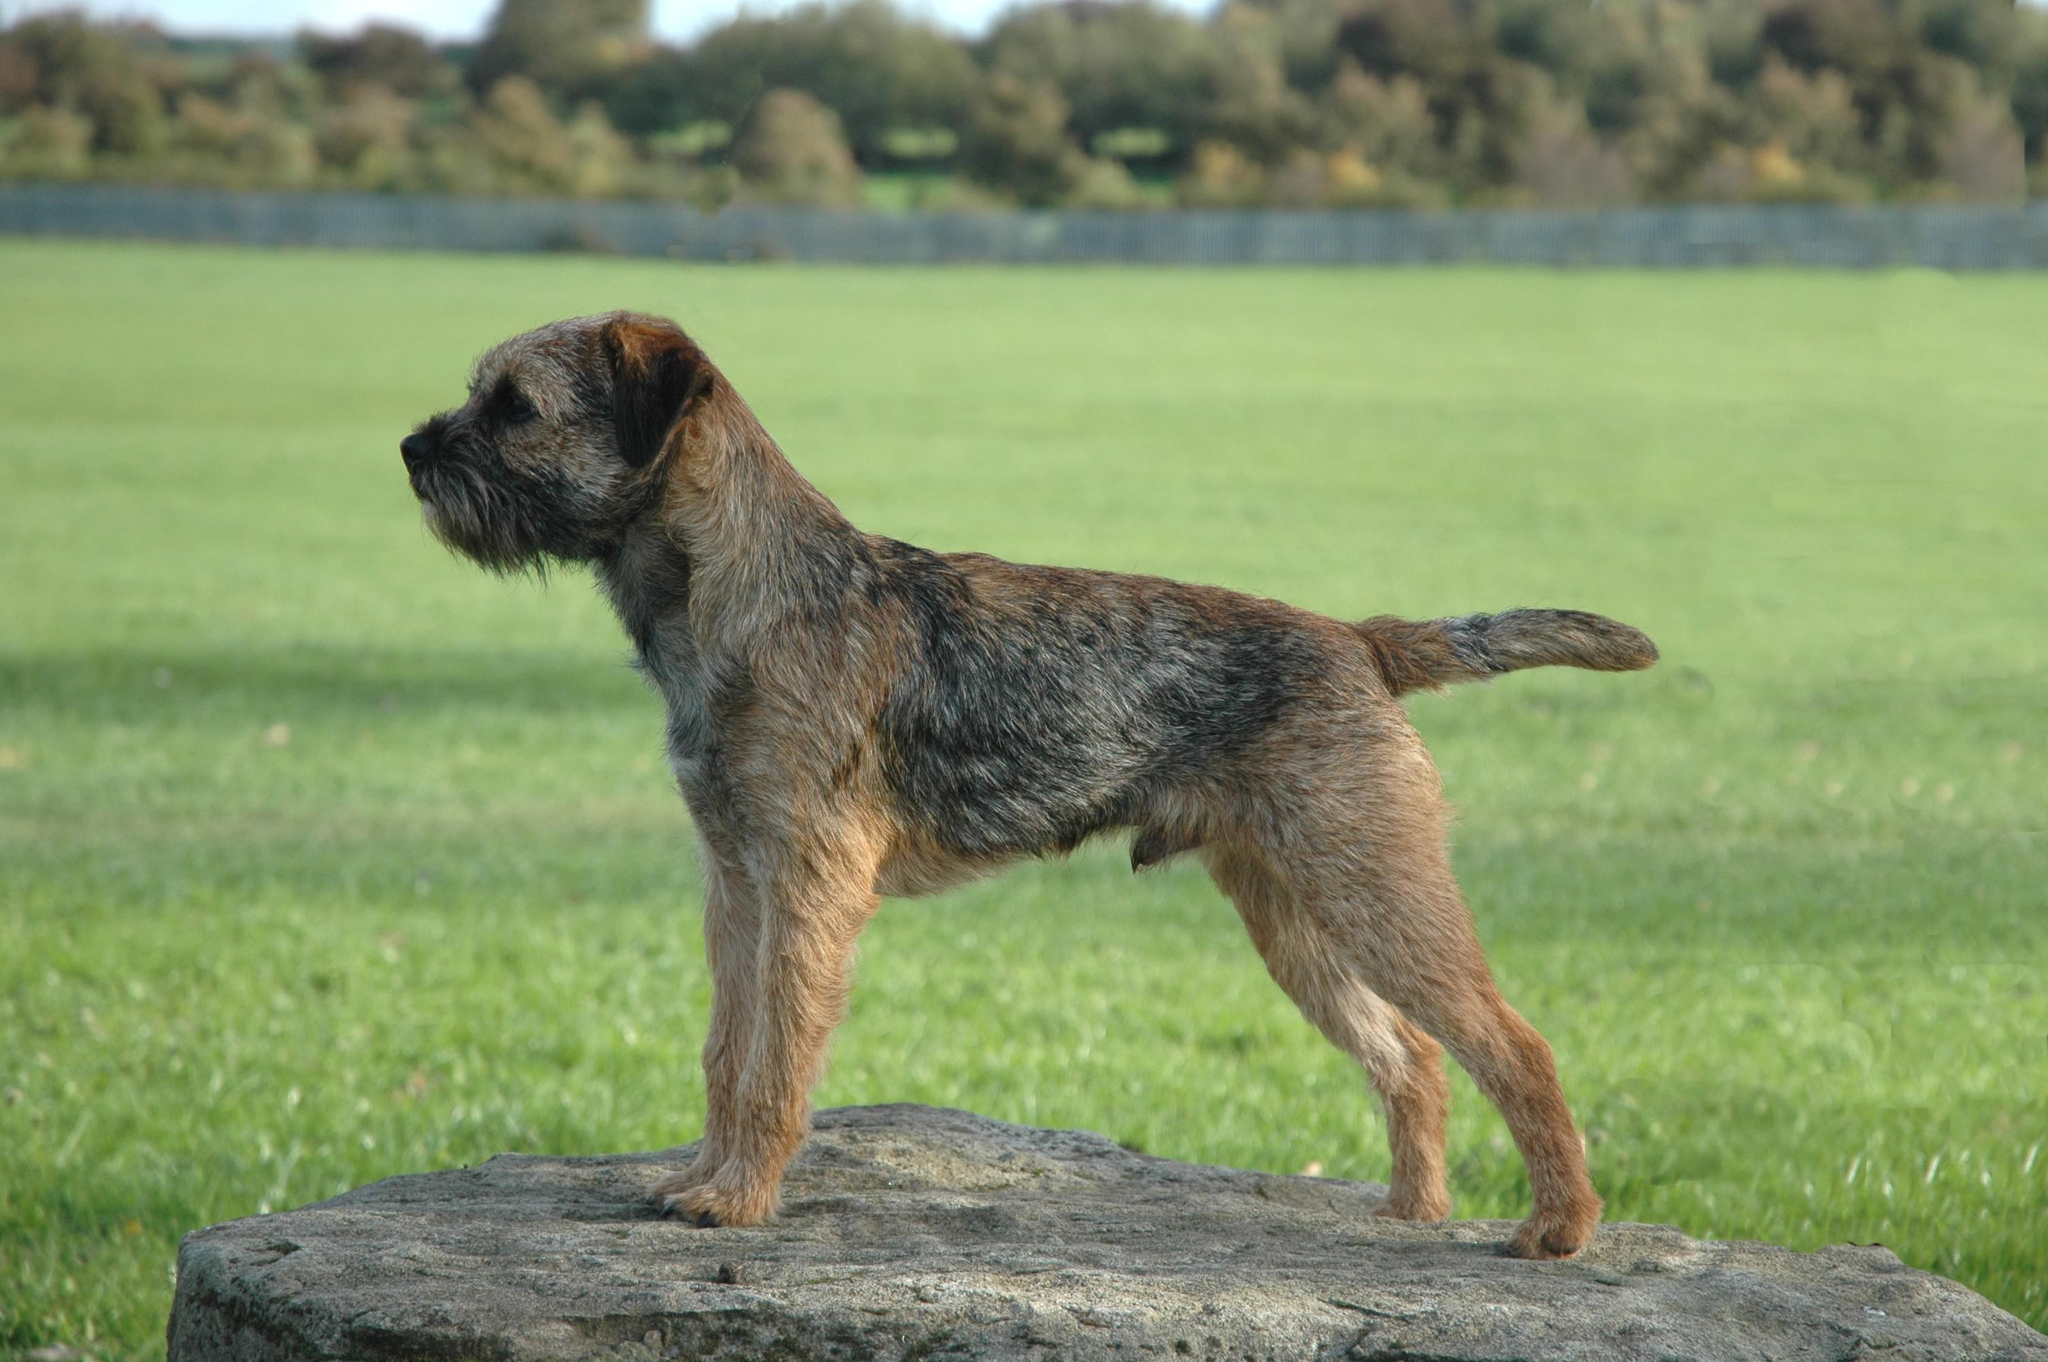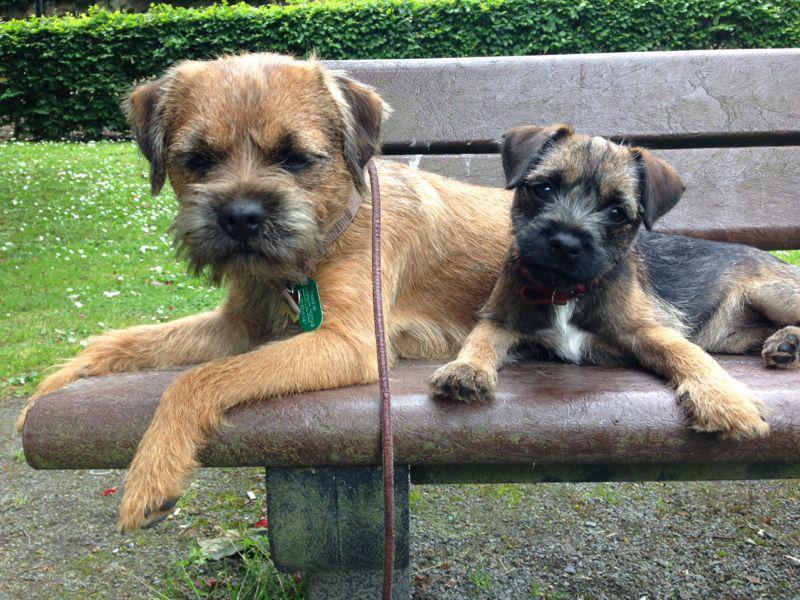The first image is the image on the left, the second image is the image on the right. For the images shown, is this caption "There are at least two dogs lying on a wood bench." true? Answer yes or no. Yes. 